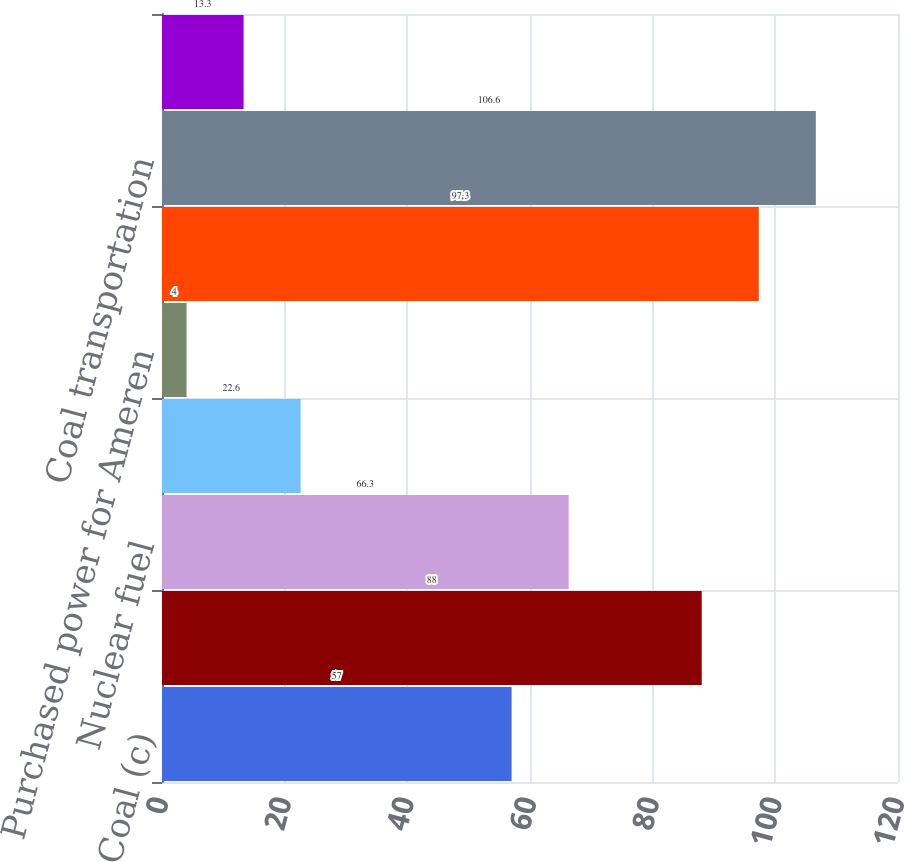<chart> <loc_0><loc_0><loc_500><loc_500><bar_chart><fcel>Coal (c)<fcel>Coal transportation (c)<fcel>Nuclear fuel<fcel>Natural gas for distribution<fcel>Purchased power for Ameren<fcel>Coal<fcel>Coal transportation<fcel>Purchased power (d)<nl><fcel>57<fcel>88<fcel>66.3<fcel>22.6<fcel>4<fcel>97.3<fcel>106.6<fcel>13.3<nl></chart> 